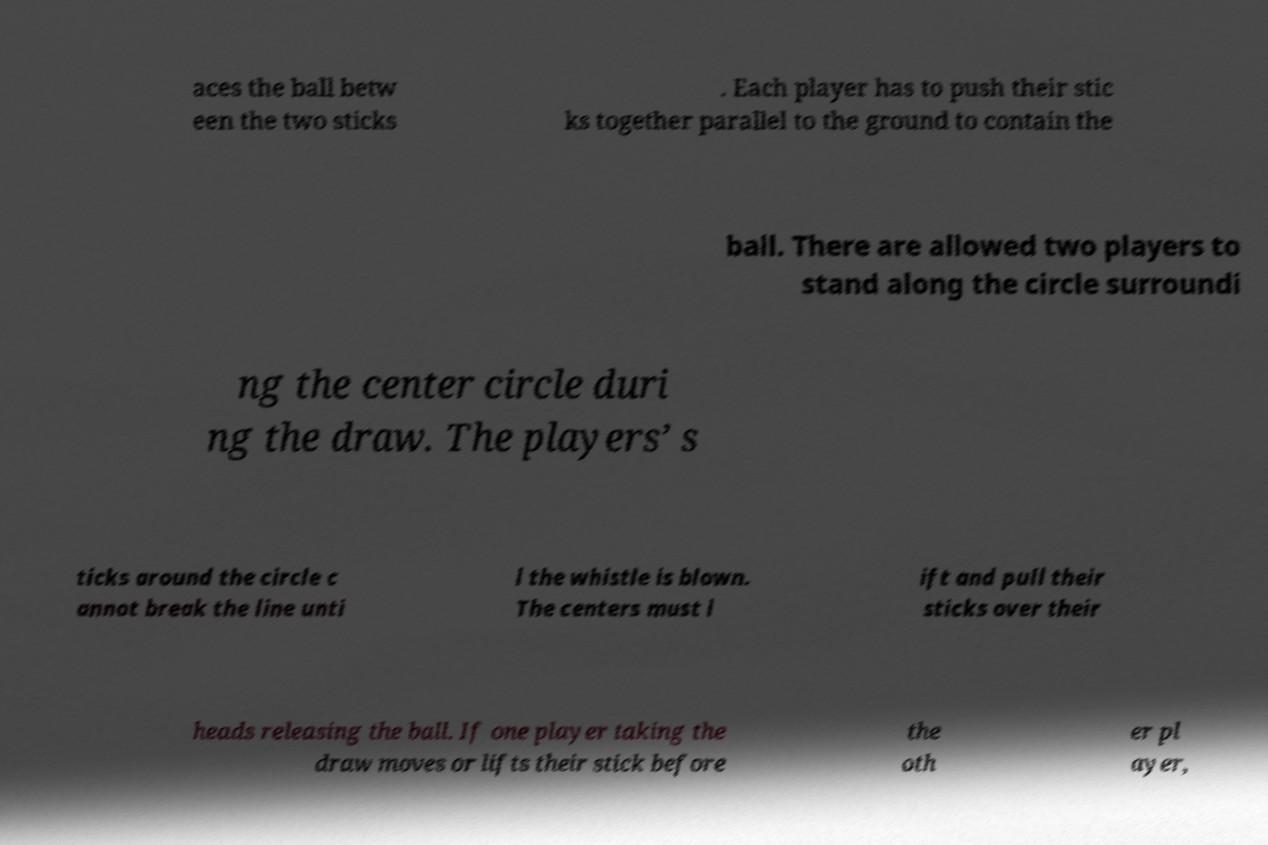Could you assist in decoding the text presented in this image and type it out clearly? aces the ball betw een the two sticks . Each player has to push their stic ks together parallel to the ground to contain the ball. There are allowed two players to stand along the circle surroundi ng the center circle duri ng the draw. The players’ s ticks around the circle c annot break the line unti l the whistle is blown. The centers must l ift and pull their sticks over their heads releasing the ball. If one player taking the draw moves or lifts their stick before the oth er pl ayer, 